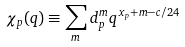Convert formula to latex. <formula><loc_0><loc_0><loc_500><loc_500>\chi _ { p } ( q ) \equiv \sum _ { m } d _ { p } ^ { m } q ^ { x _ { p } + m - c / 2 4 }</formula> 